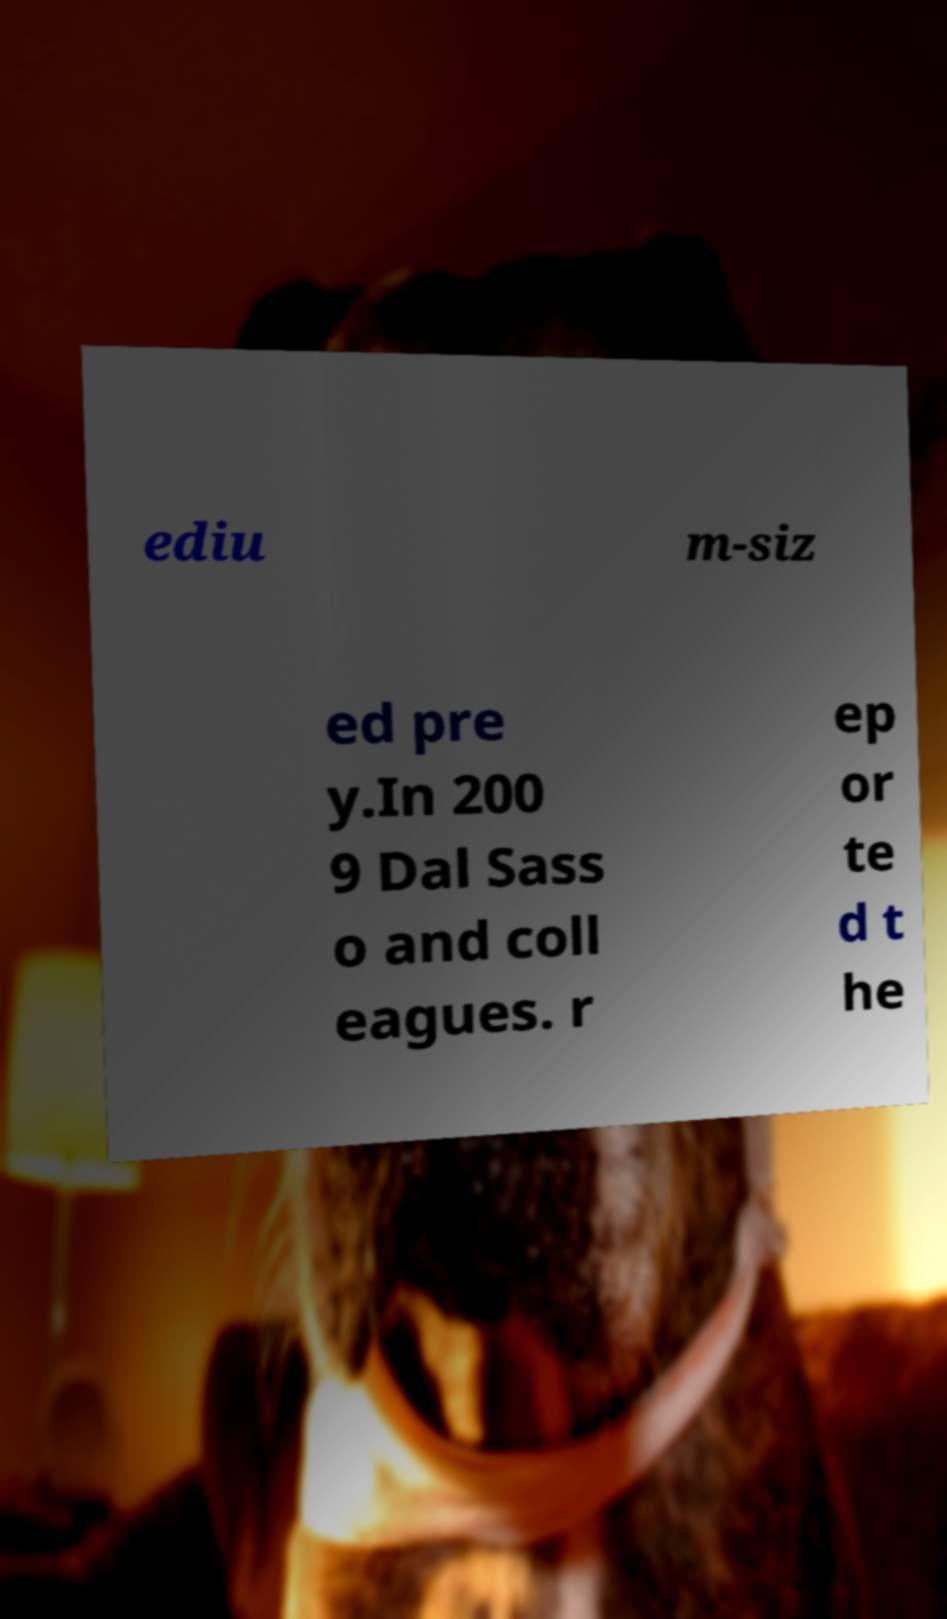Can you accurately transcribe the text from the provided image for me? ediu m-siz ed pre y.In 200 9 Dal Sass o and coll eagues. r ep or te d t he 